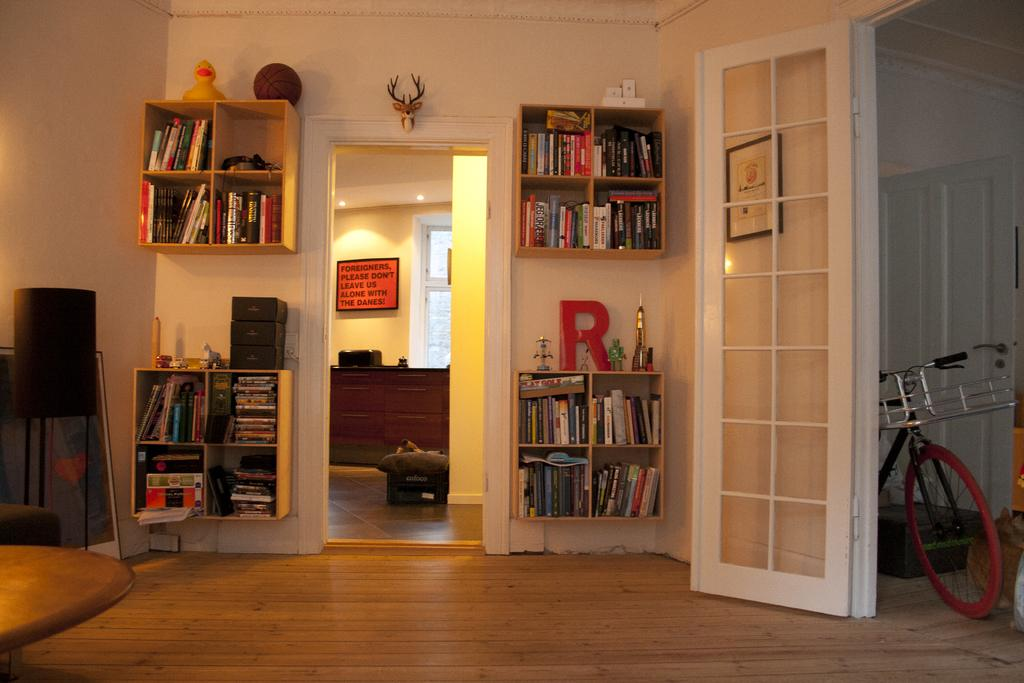<image>
Write a terse but informative summary of the picture. The letter R is displayed on top of the bottom right bookcase. 